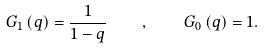<formula> <loc_0><loc_0><loc_500><loc_500>G _ { 1 } \left ( q \right ) = \frac { 1 } { 1 - q } \quad , \quad G _ { 0 } \left ( q \right ) = 1 .</formula> 